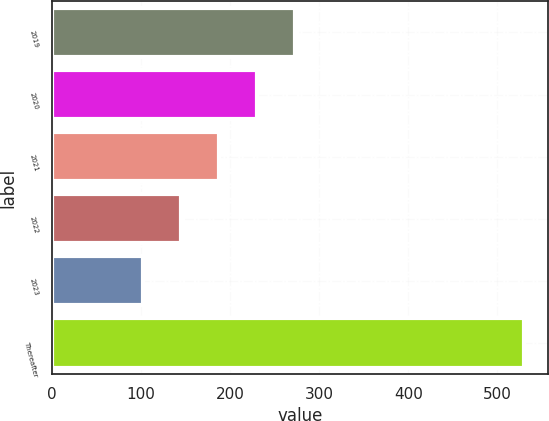Convert chart to OTSL. <chart><loc_0><loc_0><loc_500><loc_500><bar_chart><fcel>2019<fcel>2020<fcel>2021<fcel>2022<fcel>2023<fcel>Thereafter<nl><fcel>273.24<fcel>230.38<fcel>187.52<fcel>144.66<fcel>101.8<fcel>530.4<nl></chart> 